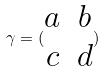Convert formula to latex. <formula><loc_0><loc_0><loc_500><loc_500>\gamma = ( \begin{matrix} a & b \\ c & d \end{matrix} )</formula> 